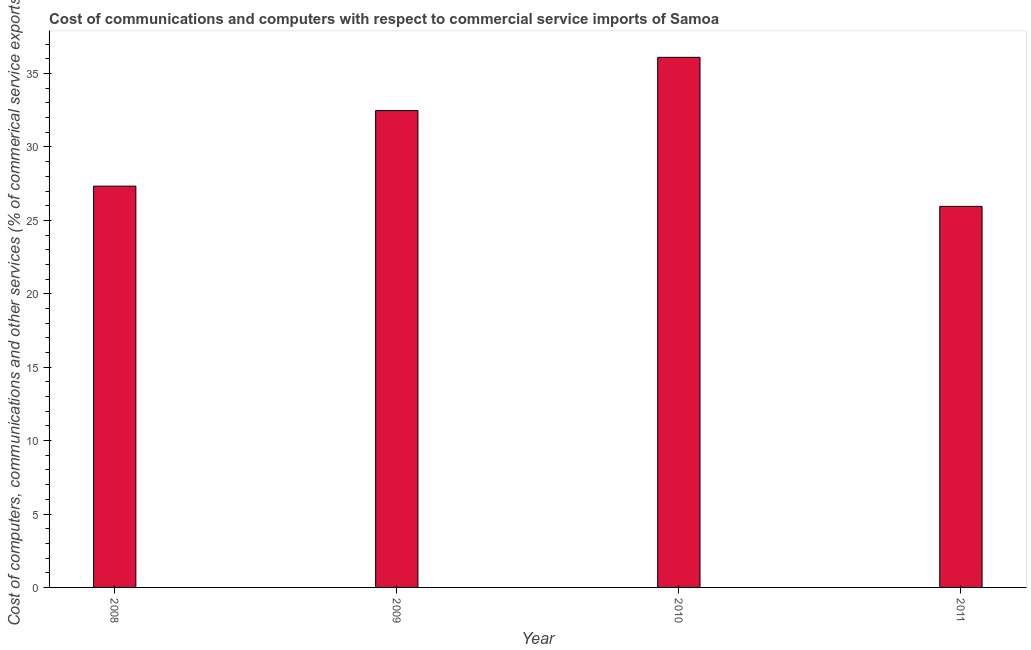Does the graph contain any zero values?
Provide a succinct answer. No. What is the title of the graph?
Provide a succinct answer. Cost of communications and computers with respect to commercial service imports of Samoa. What is the label or title of the X-axis?
Provide a short and direct response. Year. What is the label or title of the Y-axis?
Ensure brevity in your answer.  Cost of computers, communications and other services (% of commerical service exports). What is the cost of communications in 2009?
Ensure brevity in your answer.  32.48. Across all years, what is the maximum  computer and other services?
Keep it short and to the point. 36.11. Across all years, what is the minimum  computer and other services?
Offer a very short reply. 25.96. What is the sum of the  computer and other services?
Provide a succinct answer. 121.87. What is the difference between the  computer and other services in 2009 and 2010?
Provide a short and direct response. -3.63. What is the average  computer and other services per year?
Keep it short and to the point. 30.47. What is the median  computer and other services?
Keep it short and to the point. 29.91. Do a majority of the years between 2009 and 2010 (inclusive) have  computer and other services greater than 31 %?
Provide a short and direct response. Yes. What is the ratio of the cost of communications in 2008 to that in 2009?
Keep it short and to the point. 0.84. Is the cost of communications in 2008 less than that in 2010?
Keep it short and to the point. Yes. Is the difference between the  computer and other services in 2008 and 2009 greater than the difference between any two years?
Offer a very short reply. No. What is the difference between the highest and the second highest  computer and other services?
Offer a terse response. 3.63. What is the difference between the highest and the lowest cost of communications?
Make the answer very short. 10.15. How many bars are there?
Your answer should be compact. 4. What is the Cost of computers, communications and other services (% of commerical service exports) of 2008?
Offer a terse response. 27.33. What is the Cost of computers, communications and other services (% of commerical service exports) of 2009?
Give a very brief answer. 32.48. What is the Cost of computers, communications and other services (% of commerical service exports) in 2010?
Provide a succinct answer. 36.11. What is the Cost of computers, communications and other services (% of commerical service exports) in 2011?
Provide a short and direct response. 25.96. What is the difference between the Cost of computers, communications and other services (% of commerical service exports) in 2008 and 2009?
Provide a short and direct response. -5.15. What is the difference between the Cost of computers, communications and other services (% of commerical service exports) in 2008 and 2010?
Keep it short and to the point. -8.77. What is the difference between the Cost of computers, communications and other services (% of commerical service exports) in 2008 and 2011?
Ensure brevity in your answer.  1.38. What is the difference between the Cost of computers, communications and other services (% of commerical service exports) in 2009 and 2010?
Provide a succinct answer. -3.63. What is the difference between the Cost of computers, communications and other services (% of commerical service exports) in 2009 and 2011?
Offer a very short reply. 6.52. What is the difference between the Cost of computers, communications and other services (% of commerical service exports) in 2010 and 2011?
Give a very brief answer. 10.15. What is the ratio of the Cost of computers, communications and other services (% of commerical service exports) in 2008 to that in 2009?
Keep it short and to the point. 0.84. What is the ratio of the Cost of computers, communications and other services (% of commerical service exports) in 2008 to that in 2010?
Your answer should be very brief. 0.76. What is the ratio of the Cost of computers, communications and other services (% of commerical service exports) in 2008 to that in 2011?
Your answer should be compact. 1.05. What is the ratio of the Cost of computers, communications and other services (% of commerical service exports) in 2009 to that in 2010?
Provide a short and direct response. 0.9. What is the ratio of the Cost of computers, communications and other services (% of commerical service exports) in 2009 to that in 2011?
Your answer should be very brief. 1.25. What is the ratio of the Cost of computers, communications and other services (% of commerical service exports) in 2010 to that in 2011?
Provide a short and direct response. 1.39. 